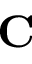<formula> <loc_0><loc_0><loc_500><loc_500>C</formula> 